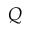Convert formula to latex. <formula><loc_0><loc_0><loc_500><loc_500>Q</formula> 